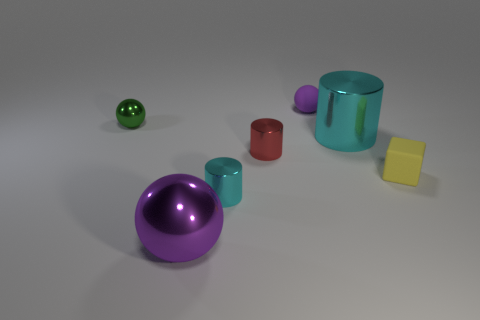How would you describe the overall mood or atmosphere of this image? The image conveys a calm and clean atmosphere, possibly due to the simplistic and orderly arrangement of shapes, the neutral background, and the soft lighting. It evokes a sense of orderliness and clarity, which might be intentionally designed to focus attention on the shapes and materials presented. 